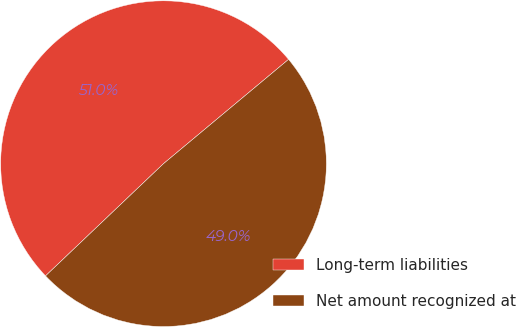Convert chart to OTSL. <chart><loc_0><loc_0><loc_500><loc_500><pie_chart><fcel>Long-term liabilities<fcel>Net amount recognized at<nl><fcel>51.04%<fcel>48.96%<nl></chart> 